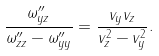Convert formula to latex. <formula><loc_0><loc_0><loc_500><loc_500>\frac { \omega ^ { \prime \prime } _ { y z } } { \omega ^ { \prime \prime } _ { z z } - \omega ^ { \prime \prime } _ { y y } } = \frac { v _ { y } v _ { z } } { v _ { z } ^ { 2 } - v _ { y } ^ { 2 } } .</formula> 